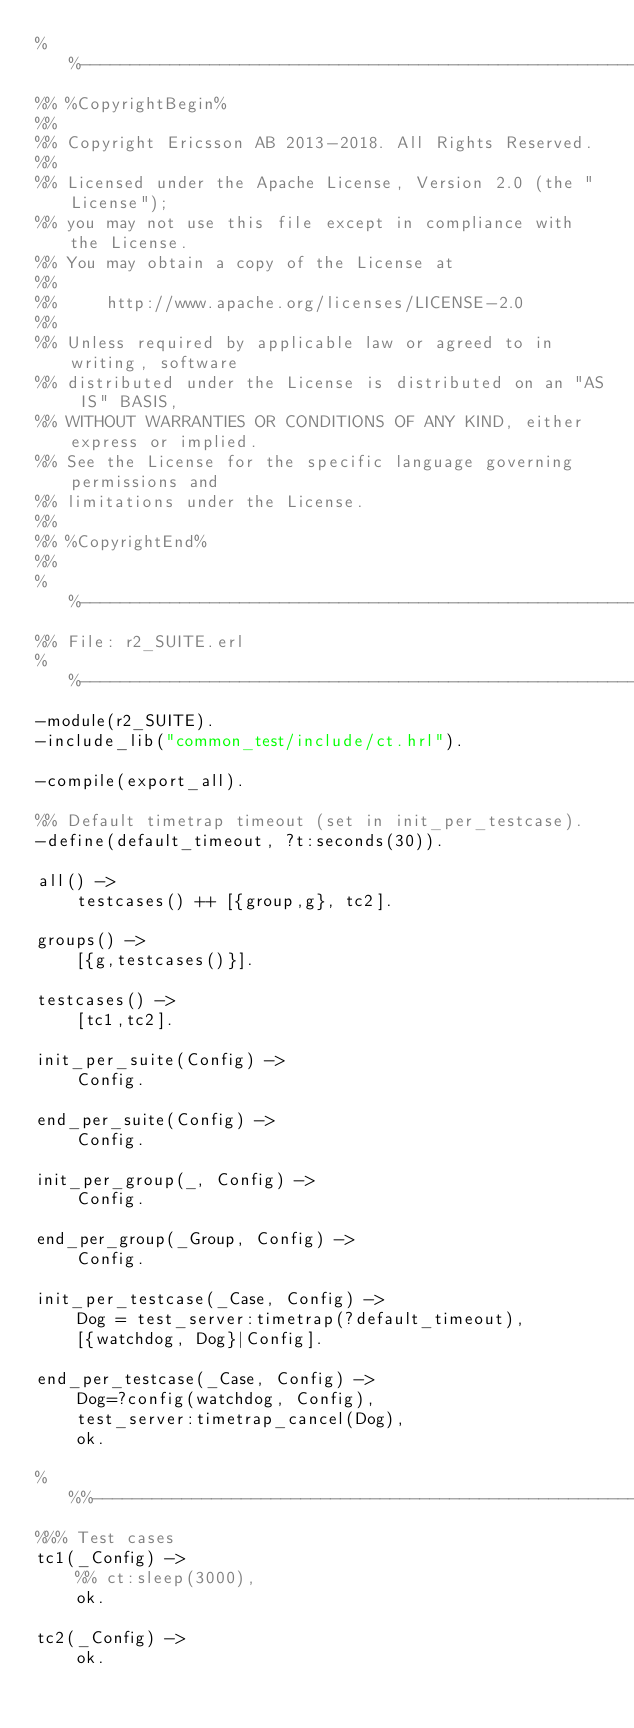<code> <loc_0><loc_0><loc_500><loc_500><_Erlang_>%%--------------------------------------------------------------------
%% %CopyrightBegin%
%%
%% Copyright Ericsson AB 2013-2018. All Rights Reserved.
%%
%% Licensed under the Apache License, Version 2.0 (the "License");
%% you may not use this file except in compliance with the License.
%% You may obtain a copy of the License at
%%
%%     http://www.apache.org/licenses/LICENSE-2.0
%%
%% Unless required by applicable law or agreed to in writing, software
%% distributed under the License is distributed on an "AS IS" BASIS,
%% WITHOUT WARRANTIES OR CONDITIONS OF ANY KIND, either express or implied.
%% See the License for the specific language governing permissions and
%% limitations under the License.
%%
%% %CopyrightEnd%
%%
%%----------------------------------------------------------------------
%% File: r2_SUITE.erl
%%----------------------------------------------------------------------
-module(r2_SUITE).
-include_lib("common_test/include/ct.hrl").

-compile(export_all).

%% Default timetrap timeout (set in init_per_testcase).
-define(default_timeout, ?t:seconds(30)).

all() ->
    testcases() ++ [{group,g}, tc2].

groups() ->
    [{g,testcases()}].

testcases() ->
    [tc1,tc2].

init_per_suite(Config) ->
    Config.

end_per_suite(Config) ->
    Config.

init_per_group(_, Config) ->
    Config.

end_per_group(_Group, Config) ->
    Config.

init_per_testcase(_Case, Config) ->
    Dog = test_server:timetrap(?default_timeout),
    [{watchdog, Dog}|Config].

end_per_testcase(_Case, Config) ->
    Dog=?config(watchdog, Config),
    test_server:timetrap_cancel(Dog),
    ok.

%%%-----------------------------------------------------------------
%%% Test cases
tc1(_Config) ->
    %% ct:sleep(3000),
    ok.

tc2(_Config) ->
    ok.
</code> 